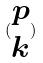Convert formula to latex. <formula><loc_0><loc_0><loc_500><loc_500>( \begin{matrix} p \\ k \end{matrix} )</formula> 